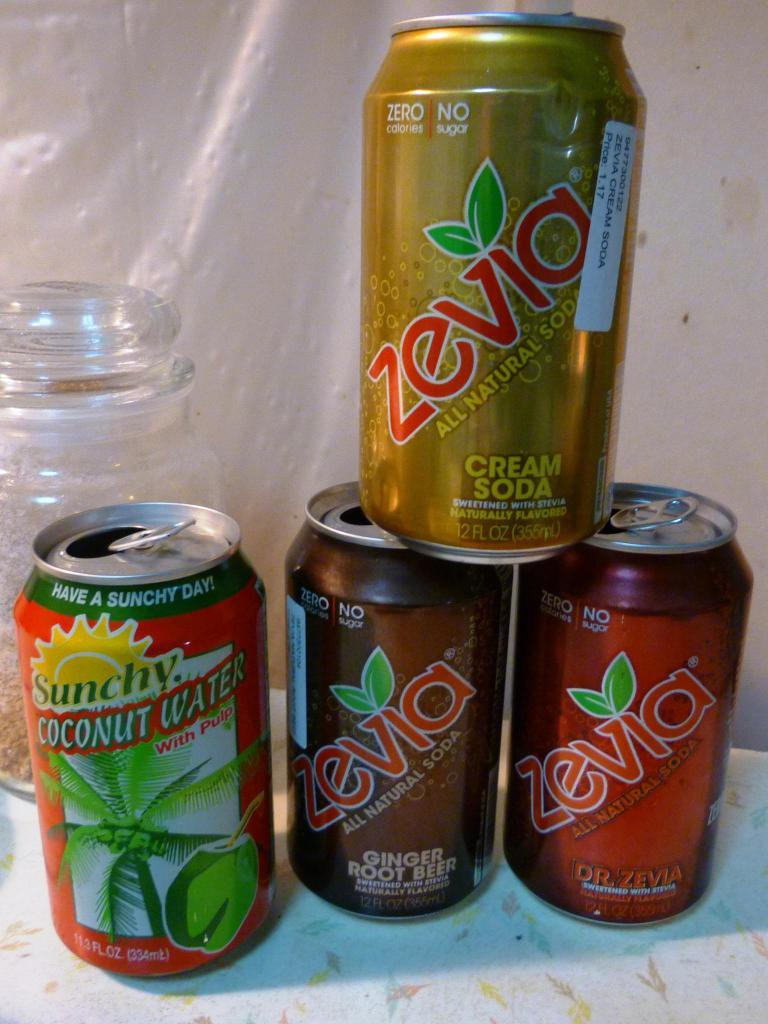Provide a one-sentence caption for the provided image. A stack of soda cans of various flavors including Cream soda, coconut water, and ginger root beer. 